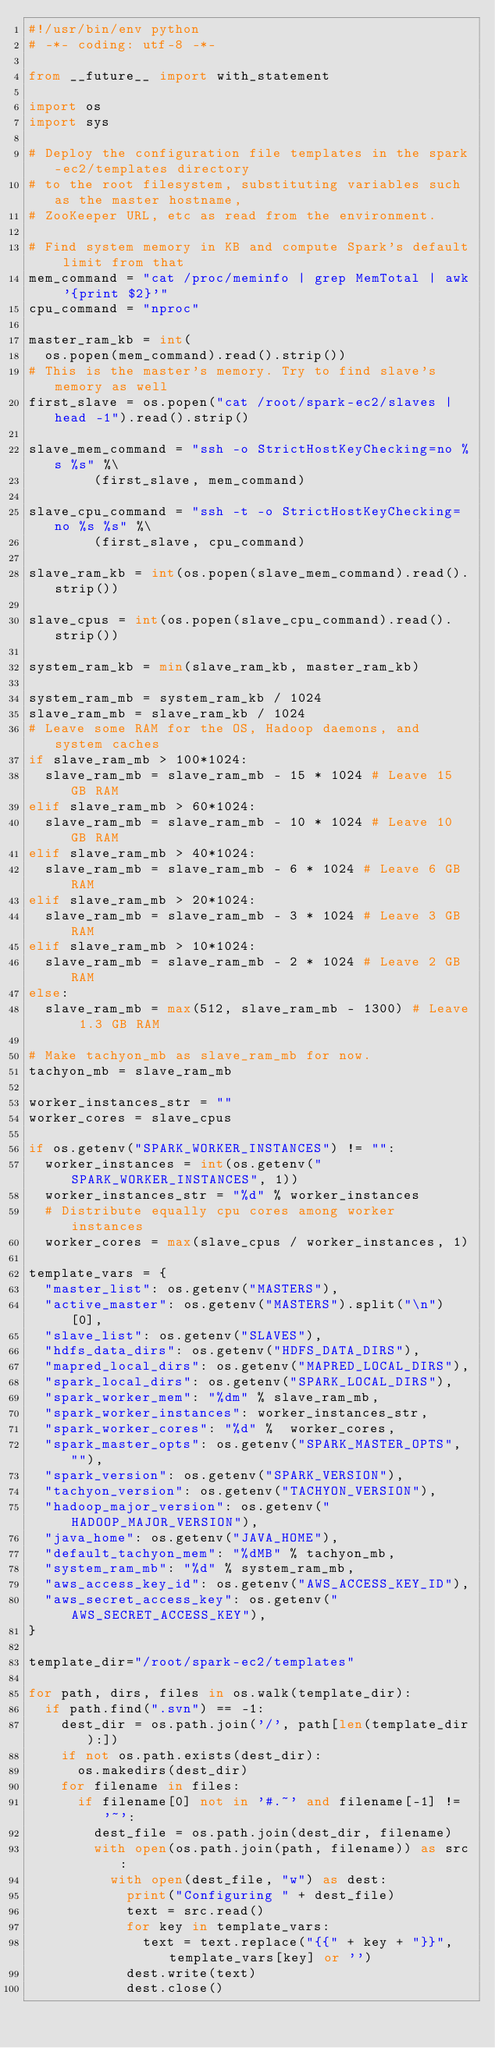Convert code to text. <code><loc_0><loc_0><loc_500><loc_500><_Python_>#!/usr/bin/env python
# -*- coding: utf-8 -*-

from __future__ import with_statement

import os
import sys

# Deploy the configuration file templates in the spark-ec2/templates directory
# to the root filesystem, substituting variables such as the master hostname,
# ZooKeeper URL, etc as read from the environment.

# Find system memory in KB and compute Spark's default limit from that
mem_command = "cat /proc/meminfo | grep MemTotal | awk '{print $2}'"
cpu_command = "nproc"

master_ram_kb = int(
  os.popen(mem_command).read().strip())
# This is the master's memory. Try to find slave's memory as well
first_slave = os.popen("cat /root/spark-ec2/slaves | head -1").read().strip()

slave_mem_command = "ssh -o StrictHostKeyChecking=no %s %s" %\
        (first_slave, mem_command)

slave_cpu_command = "ssh -t -o StrictHostKeyChecking=no %s %s" %\
        (first_slave, cpu_command)

slave_ram_kb = int(os.popen(slave_mem_command).read().strip())

slave_cpus = int(os.popen(slave_cpu_command).read().strip())

system_ram_kb = min(slave_ram_kb, master_ram_kb)

system_ram_mb = system_ram_kb / 1024
slave_ram_mb = slave_ram_kb / 1024
# Leave some RAM for the OS, Hadoop daemons, and system caches
if slave_ram_mb > 100*1024:
  slave_ram_mb = slave_ram_mb - 15 * 1024 # Leave 15 GB RAM
elif slave_ram_mb > 60*1024:
  slave_ram_mb = slave_ram_mb - 10 * 1024 # Leave 10 GB RAM
elif slave_ram_mb > 40*1024:
  slave_ram_mb = slave_ram_mb - 6 * 1024 # Leave 6 GB RAM
elif slave_ram_mb > 20*1024:
  slave_ram_mb = slave_ram_mb - 3 * 1024 # Leave 3 GB RAM
elif slave_ram_mb > 10*1024:
  slave_ram_mb = slave_ram_mb - 2 * 1024 # Leave 2 GB RAM
else:
  slave_ram_mb = max(512, slave_ram_mb - 1300) # Leave 1.3 GB RAM

# Make tachyon_mb as slave_ram_mb for now.
tachyon_mb = slave_ram_mb

worker_instances_str = ""
worker_cores = slave_cpus

if os.getenv("SPARK_WORKER_INSTANCES") != "":
  worker_instances = int(os.getenv("SPARK_WORKER_INSTANCES", 1))
  worker_instances_str = "%d" % worker_instances
  # Distribute equally cpu cores among worker instances
  worker_cores = max(slave_cpus / worker_instances, 1)

template_vars = {
  "master_list": os.getenv("MASTERS"),
  "active_master": os.getenv("MASTERS").split("\n")[0],
  "slave_list": os.getenv("SLAVES"),
  "hdfs_data_dirs": os.getenv("HDFS_DATA_DIRS"),
  "mapred_local_dirs": os.getenv("MAPRED_LOCAL_DIRS"),
  "spark_local_dirs": os.getenv("SPARK_LOCAL_DIRS"),
  "spark_worker_mem": "%dm" % slave_ram_mb,
  "spark_worker_instances": worker_instances_str,
  "spark_worker_cores": "%d" %  worker_cores,
  "spark_master_opts": os.getenv("SPARK_MASTER_OPTS", ""),
  "spark_version": os.getenv("SPARK_VERSION"),
  "tachyon_version": os.getenv("TACHYON_VERSION"),
  "hadoop_major_version": os.getenv("HADOOP_MAJOR_VERSION"),
  "java_home": os.getenv("JAVA_HOME"),
  "default_tachyon_mem": "%dMB" % tachyon_mb,
  "system_ram_mb": "%d" % system_ram_mb,
  "aws_access_key_id": os.getenv("AWS_ACCESS_KEY_ID"),
  "aws_secret_access_key": os.getenv("AWS_SECRET_ACCESS_KEY"),
}

template_dir="/root/spark-ec2/templates"

for path, dirs, files in os.walk(template_dir):
  if path.find(".svn") == -1:
    dest_dir = os.path.join('/', path[len(template_dir):])
    if not os.path.exists(dest_dir):
      os.makedirs(dest_dir)
    for filename in files:
      if filename[0] not in '#.~' and filename[-1] != '~':
        dest_file = os.path.join(dest_dir, filename)
        with open(os.path.join(path, filename)) as src:
          with open(dest_file, "w") as dest:
            print("Configuring " + dest_file)
            text = src.read()
            for key in template_vars:
              text = text.replace("{{" + key + "}}", template_vars[key] or '')
            dest.write(text)
            dest.close()
</code> 